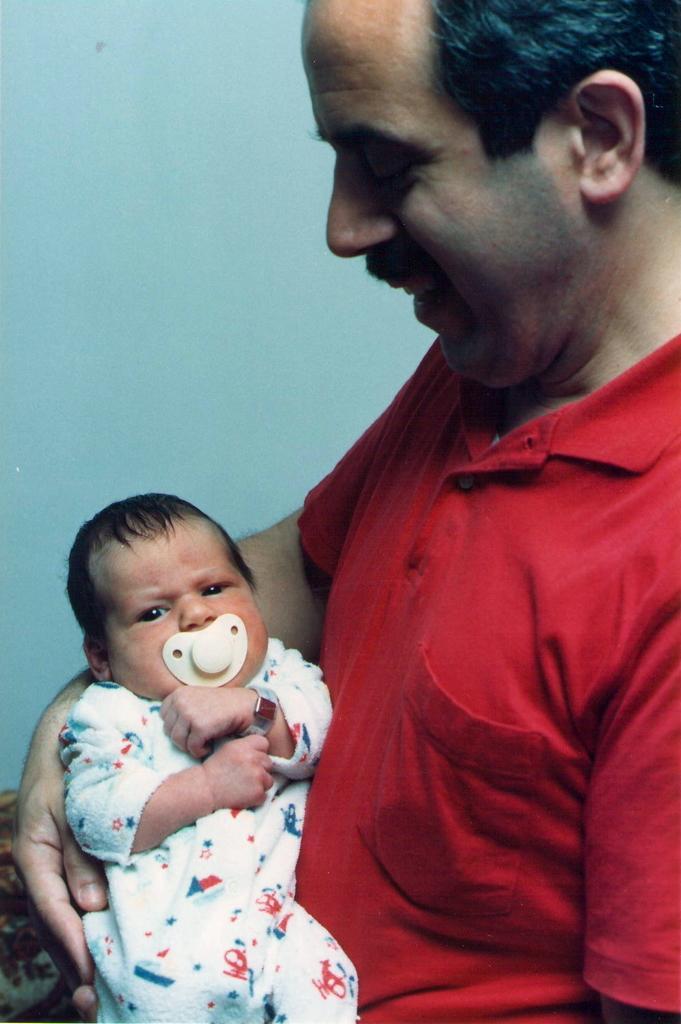In one or two sentences, can you explain what this image depicts? In this image there is a man wearing a red t-shirt is holding a baby. He is smiling. In the background the wall is blue. 